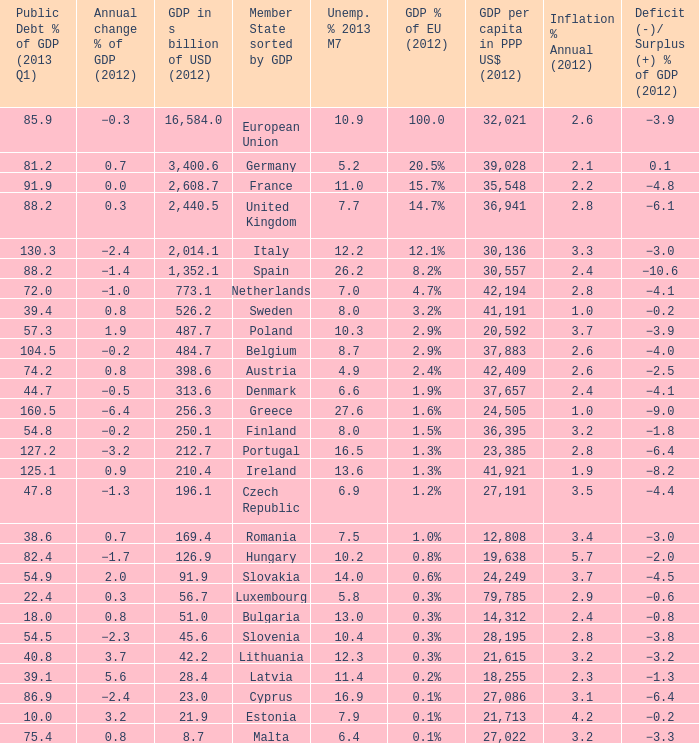What is the GDP % of EU in 2012 of the country with a GDP in billions of USD in 2012 of 256.3? 1.6%. 